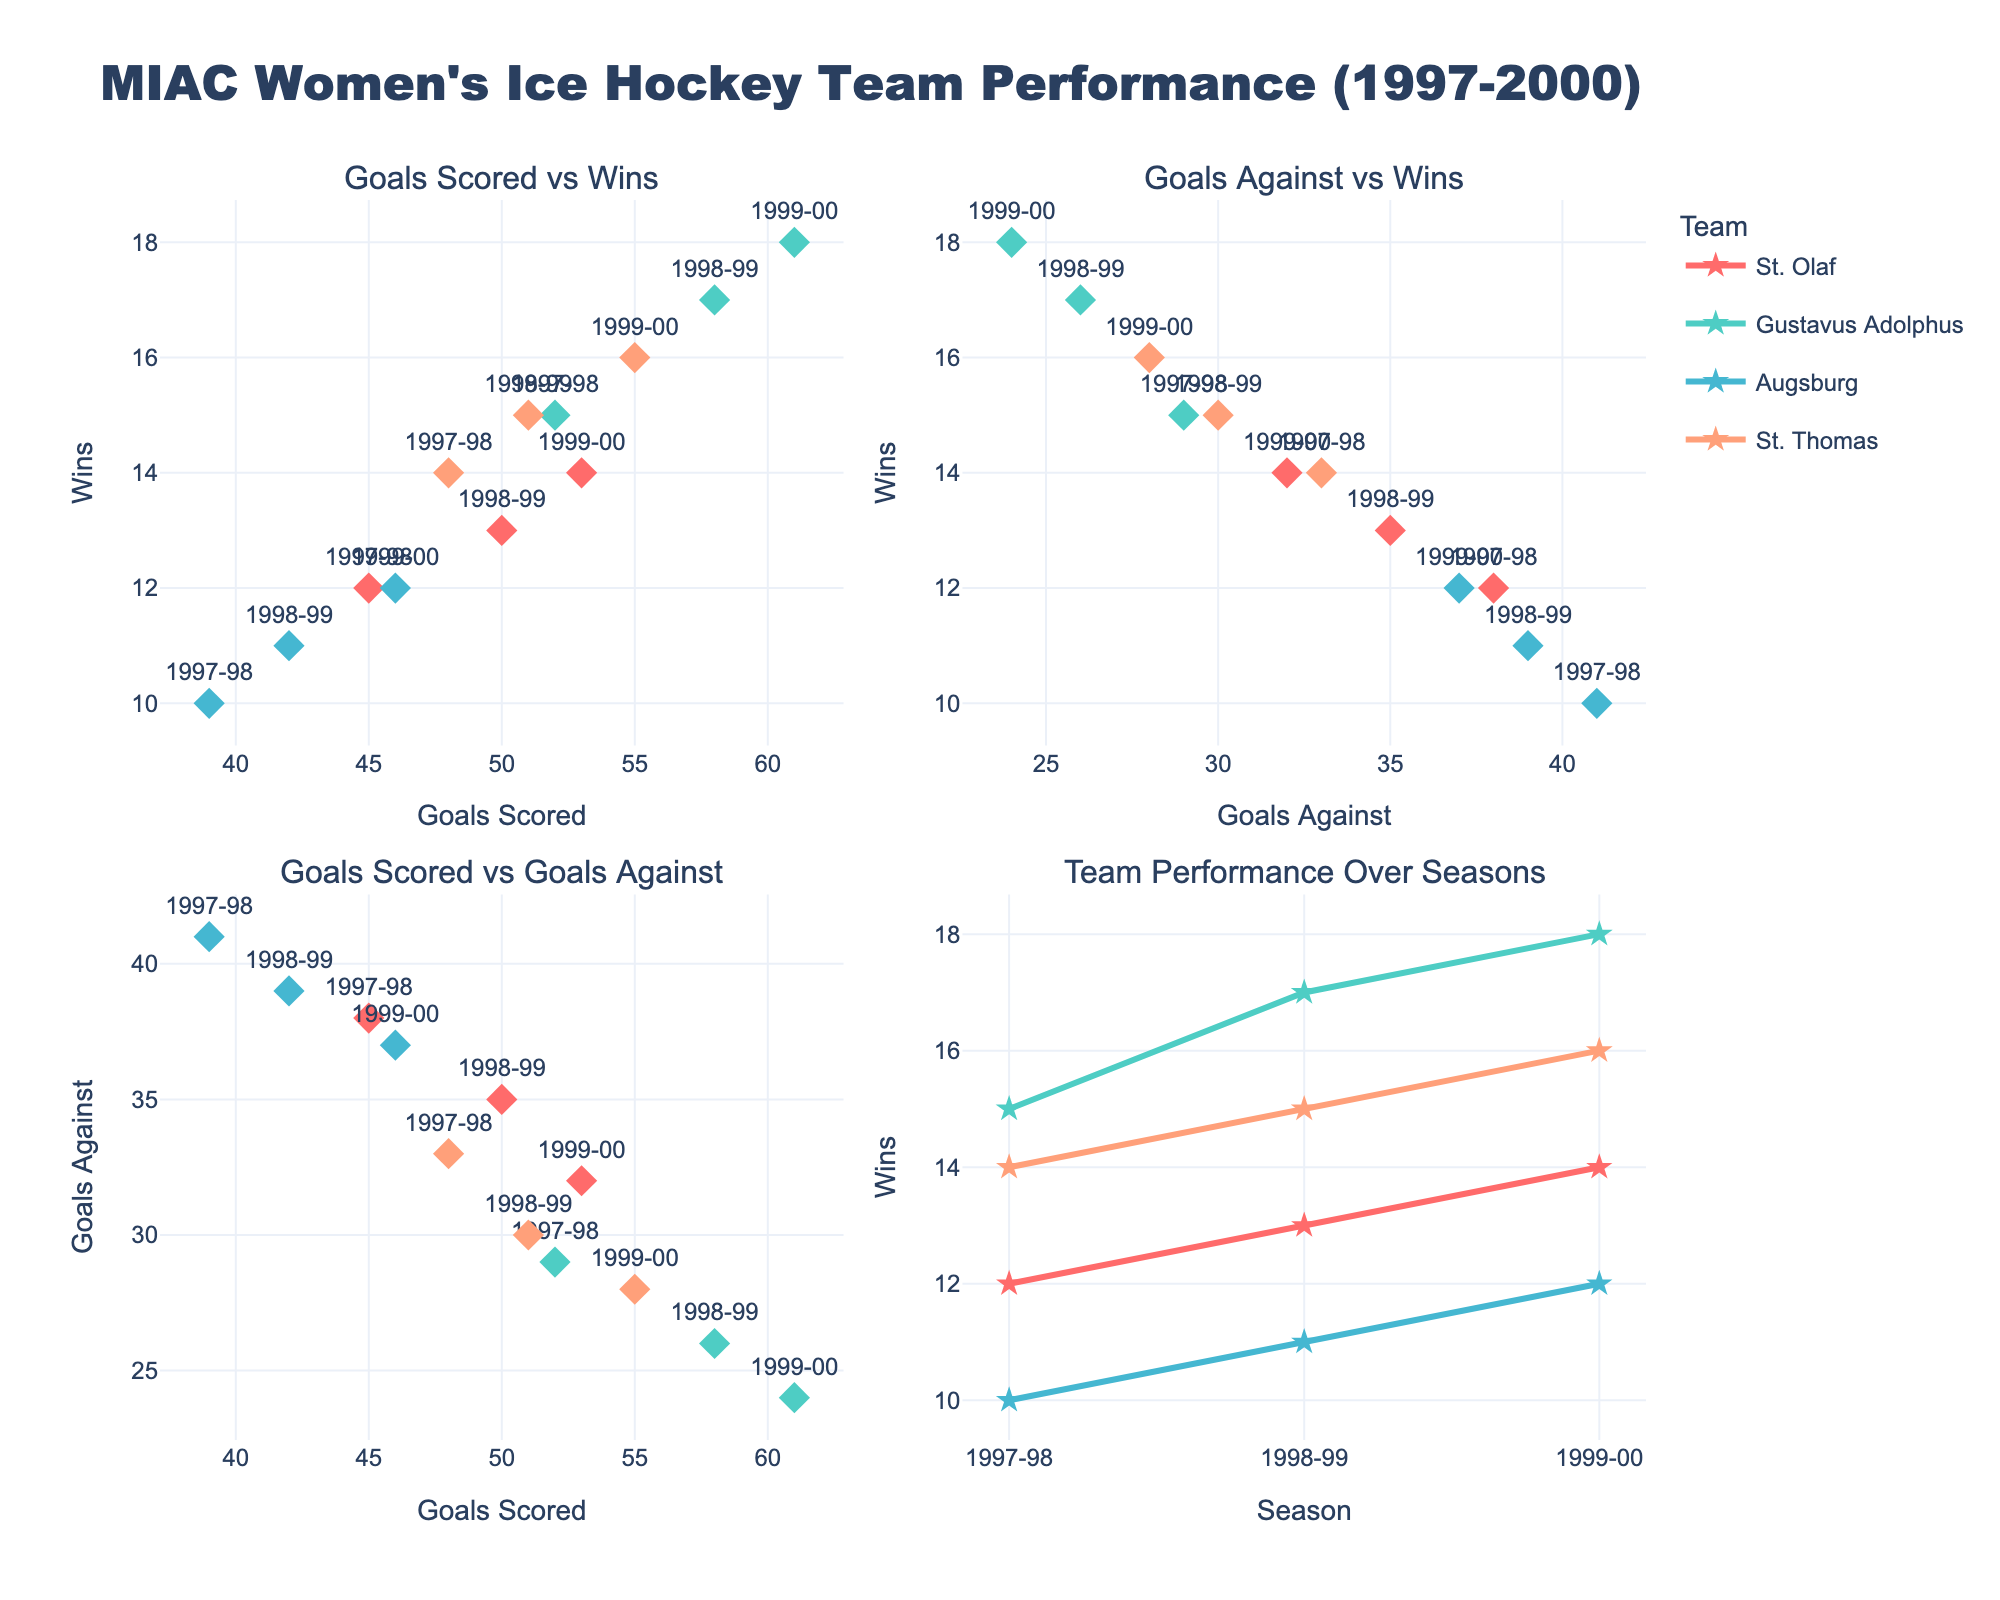How many teams are represented in the figure? By looking at the different legends and traces, we can see there are four teams: St. Olaf, Gustavus Adolphus, Augsburg, and St. Thomas.
Answer: Four How many seasons are displayed in the figure? Each scatter plot includes markers for the seasons 1997-98, 1998-99, and 1999-00, indicating three different seasons.
Answer: Three Which subplot shows the relationship between goals scored and wins? The title of the first subplot is "Goals Scored vs Wins," which indicates that it displays the relationship between goals scored and wins.
Answer: The first subplot Which team scored the most goals in the 1999-00 season? By looking at the "Goals Scored vs Wins" and "Goals Scored vs Goals Against" subplots, Gustavus Adolphus scored the most goals in the 1999-00 season with 61 goals.
Answer: Gustavus Adolphus Is there a general trend in wins based on goals scored? Observing the first subplot, there is a general positive correlation between goals scored and wins; teams that scored more goals generally had more wins.
Answer: Positive correlation Which team allowed the fewest goals against in any given season? From the "Goals Against vs Wins" subplot, Gustavus Adolphus had the fewest goals against in the 1999-00 season with 24 goals against.
Answer: Gustavus Adolphus How did St. Thomas' performance in terms of wins change over the three seasons? Referring to the "Team Performance Over Seasons" subplot, the number of wins for St. Thomas increased from 14 in 1997-98 to 15 in 1998-99 and then to 16 in 1999-00.
Answer: Increased Which season did St. Olaf have the least number of wins? In the "Team Performance Over Seasons" subplot, St. Olaf had the least number of wins in the 1997-98 season with 12 wins.
Answer: 1997-98 Between which two teams is the difference in goals scored the smallest in the 1998-99 season? Checking data points in the "Goals Scored vs Wins" subplot, St. Thomas scored 51 goals and St. Olaf scored 50 goals, making the difference just 1 goal.
Answer: St. Thomas and St. Olaf 